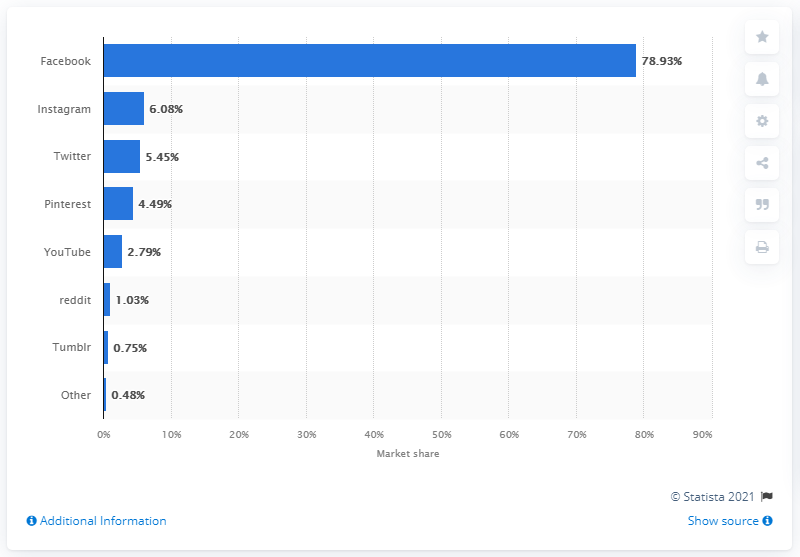Outline some significant characteristics in this image. Instagram was Sweden's second largest social network. Twitter accounted for approximately 5.45% of all page views in Sweden. As of May 2021, Facebook had a market share of 78.93% in Sweden. 